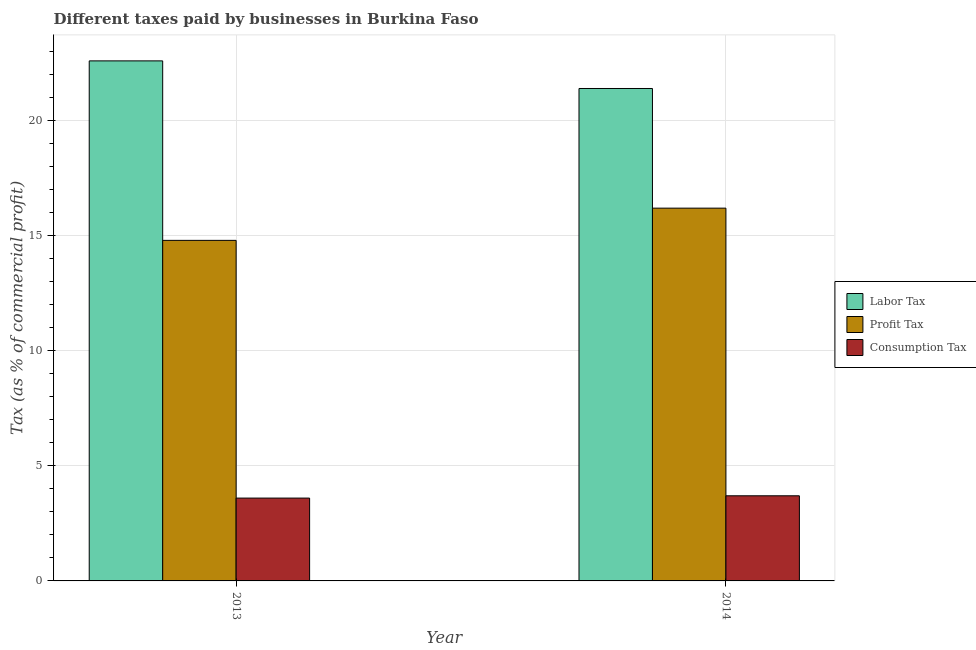Are the number of bars on each tick of the X-axis equal?
Offer a very short reply. Yes. How many bars are there on the 2nd tick from the left?
Your answer should be compact. 3. How many bars are there on the 2nd tick from the right?
Keep it short and to the point. 3. In how many cases, is the number of bars for a given year not equal to the number of legend labels?
Your answer should be very brief. 0. What is the percentage of profit tax in 2013?
Make the answer very short. 14.8. Across all years, what is the maximum percentage of profit tax?
Offer a terse response. 16.2. Across all years, what is the minimum percentage of consumption tax?
Your answer should be very brief. 3.6. In which year was the percentage of labor tax maximum?
Your answer should be very brief. 2013. What is the difference between the percentage of profit tax in 2013 and that in 2014?
Make the answer very short. -1.4. What is the difference between the percentage of profit tax in 2013 and the percentage of consumption tax in 2014?
Provide a short and direct response. -1.4. What is the average percentage of consumption tax per year?
Ensure brevity in your answer.  3.65. In how many years, is the percentage of consumption tax greater than 7 %?
Your answer should be compact. 0. What is the ratio of the percentage of labor tax in 2013 to that in 2014?
Offer a very short reply. 1.06. Is the percentage of labor tax in 2013 less than that in 2014?
Your answer should be very brief. No. What does the 3rd bar from the left in 2013 represents?
Your answer should be very brief. Consumption Tax. What does the 2nd bar from the right in 2013 represents?
Keep it short and to the point. Profit Tax. Is it the case that in every year, the sum of the percentage of labor tax and percentage of profit tax is greater than the percentage of consumption tax?
Your answer should be very brief. Yes. Are all the bars in the graph horizontal?
Give a very brief answer. No. How many years are there in the graph?
Make the answer very short. 2. Does the graph contain any zero values?
Your answer should be very brief. No. How many legend labels are there?
Provide a succinct answer. 3. How are the legend labels stacked?
Offer a very short reply. Vertical. What is the title of the graph?
Offer a terse response. Different taxes paid by businesses in Burkina Faso. Does "Taxes on income" appear as one of the legend labels in the graph?
Keep it short and to the point. No. What is the label or title of the Y-axis?
Ensure brevity in your answer.  Tax (as % of commercial profit). What is the Tax (as % of commercial profit) in Labor Tax in 2013?
Provide a short and direct response. 22.6. What is the Tax (as % of commercial profit) in Labor Tax in 2014?
Keep it short and to the point. 21.4. Across all years, what is the maximum Tax (as % of commercial profit) of Labor Tax?
Your response must be concise. 22.6. Across all years, what is the minimum Tax (as % of commercial profit) in Labor Tax?
Your answer should be compact. 21.4. Across all years, what is the minimum Tax (as % of commercial profit) in Profit Tax?
Offer a very short reply. 14.8. Across all years, what is the minimum Tax (as % of commercial profit) in Consumption Tax?
Provide a succinct answer. 3.6. What is the difference between the Tax (as % of commercial profit) in Profit Tax in 2013 and that in 2014?
Your response must be concise. -1.4. What is the average Tax (as % of commercial profit) of Consumption Tax per year?
Your answer should be very brief. 3.65. In the year 2013, what is the difference between the Tax (as % of commercial profit) in Labor Tax and Tax (as % of commercial profit) in Profit Tax?
Ensure brevity in your answer.  7.8. In the year 2013, what is the difference between the Tax (as % of commercial profit) of Labor Tax and Tax (as % of commercial profit) of Consumption Tax?
Make the answer very short. 19. In the year 2014, what is the difference between the Tax (as % of commercial profit) of Labor Tax and Tax (as % of commercial profit) of Profit Tax?
Your answer should be very brief. 5.2. In the year 2014, what is the difference between the Tax (as % of commercial profit) of Labor Tax and Tax (as % of commercial profit) of Consumption Tax?
Your answer should be very brief. 17.7. In the year 2014, what is the difference between the Tax (as % of commercial profit) of Profit Tax and Tax (as % of commercial profit) of Consumption Tax?
Make the answer very short. 12.5. What is the ratio of the Tax (as % of commercial profit) of Labor Tax in 2013 to that in 2014?
Your answer should be compact. 1.06. What is the ratio of the Tax (as % of commercial profit) of Profit Tax in 2013 to that in 2014?
Offer a terse response. 0.91. What is the difference between the highest and the second highest Tax (as % of commercial profit) of Labor Tax?
Give a very brief answer. 1.2. What is the difference between the highest and the second highest Tax (as % of commercial profit) of Profit Tax?
Your answer should be very brief. 1.4. What is the difference between the highest and the lowest Tax (as % of commercial profit) of Profit Tax?
Give a very brief answer. 1.4. What is the difference between the highest and the lowest Tax (as % of commercial profit) in Consumption Tax?
Keep it short and to the point. 0.1. 